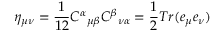<formula> <loc_0><loc_0><loc_500><loc_500>\eta _ { \mu \nu } = \frac { 1 } { 1 2 } { C ^ { \alpha } } _ { \mu \beta } { C ^ { \beta } } _ { \nu \alpha } = \frac { 1 } { 2 } T r ( e _ { \mu } e _ { \nu } )</formula> 